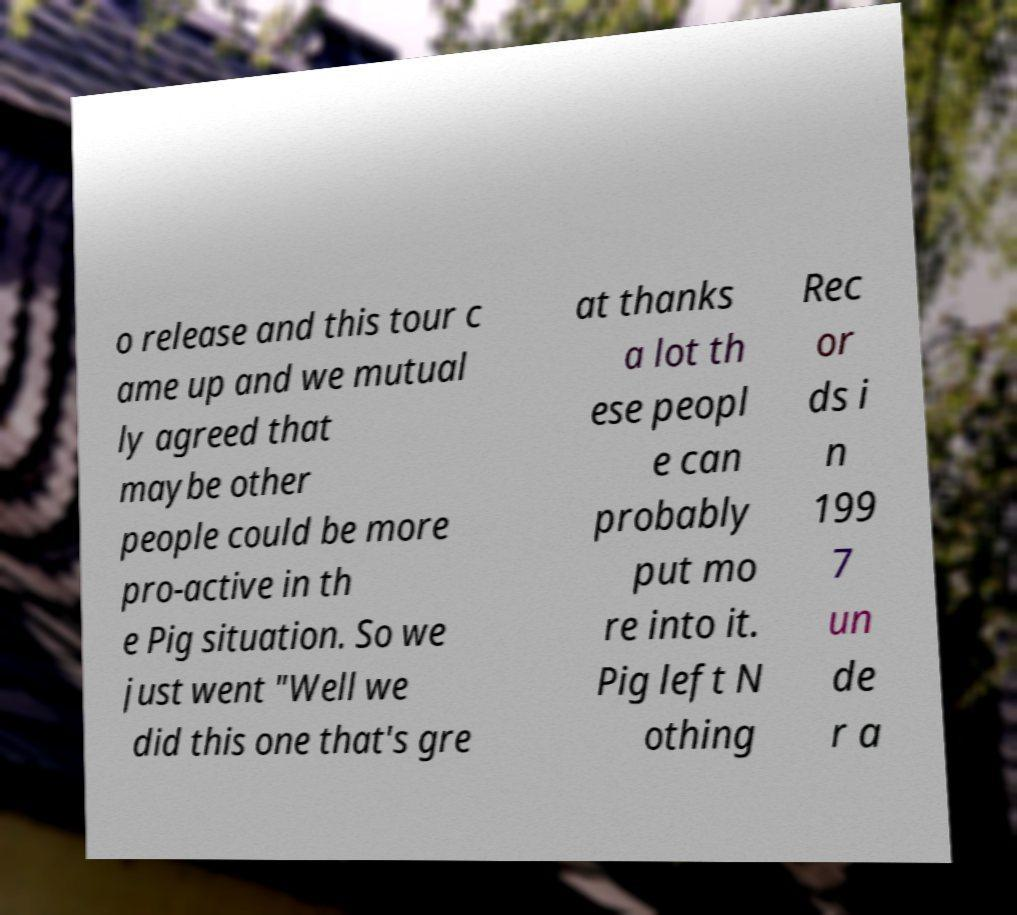There's text embedded in this image that I need extracted. Can you transcribe it verbatim? o release and this tour c ame up and we mutual ly agreed that maybe other people could be more pro-active in th e Pig situation. So we just went "Well we did this one that's gre at thanks a lot th ese peopl e can probably put mo re into it. Pig left N othing Rec or ds i n 199 7 un de r a 